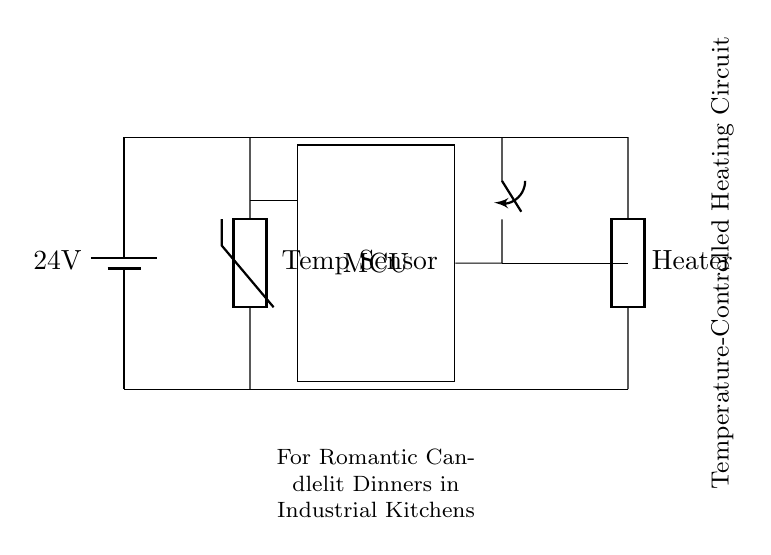What is the voltage of the power supply in this circuit? The circuit diagram indicates a battery labeled with a voltage of 24 volts. This value represents the potential difference supplied to the circuit components.
Answer: 24 volts What component controls the heating element? The microcontroller, represented in the diagram as a rectangle, is connected to the relay that controls the heating element, enabling it to turn on or off based on temperature readings.
Answer: Microcontroller What type of sensor is used in this circuit? The diagram labels the sensor as a thermistor, which measures temperature and provides input to the microcontroller for processing and control decisions.
Answer: Thermistor How does the temperature sensor affect the heating element? The thermistor provides temperature data to the microcontroller, allowing it to determine if the relay should be activated to heat the element. The response depends on whether a predefined temperature threshold is met.
Answer: Temperature control What is the purpose of the relay in this circuit? The relay serves as a switch that opens or closes the circuit to the heating element based on commands from the microcontroller, allowing it to control the heating based on the sensor's input.
Answer: Switching device What is the overall goal of this heating circuit design? The design promotes a temperature-controlled environment to achieve optimal heating conditions for romantic candlelit dinners, particularly in an industrial kitchen setting.
Answer: Maintain temperature 